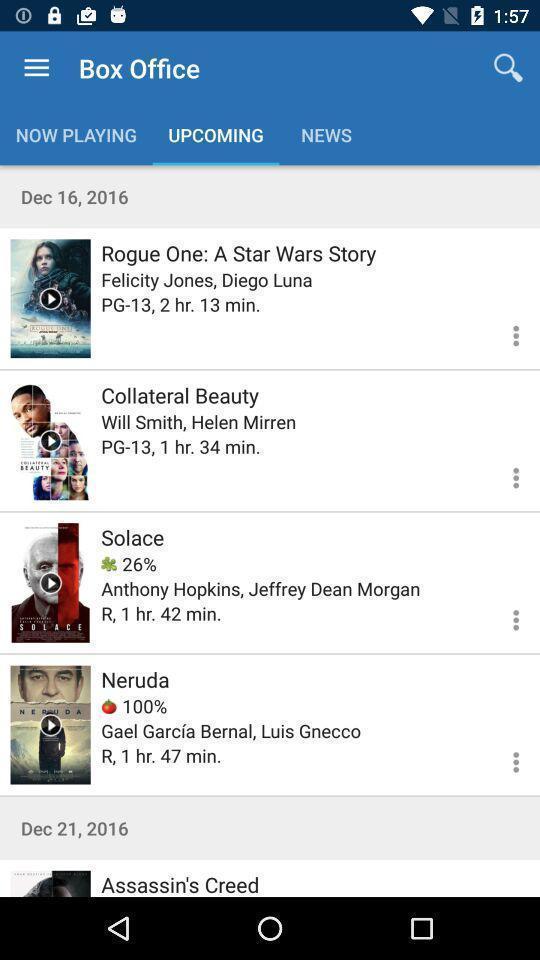Provide a textual representation of this image. Page with list of movies for watching. 